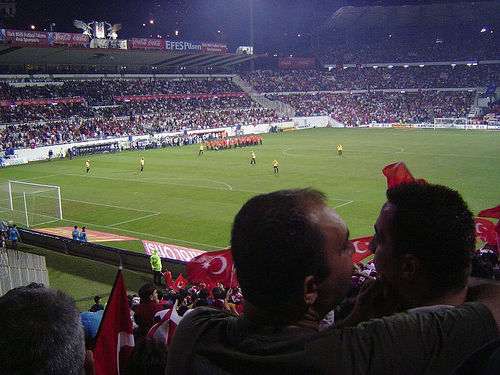<image>
Is the person on the field? No. The person is not positioned on the field. They may be near each other, but the person is not supported by or resting on top of the field. 